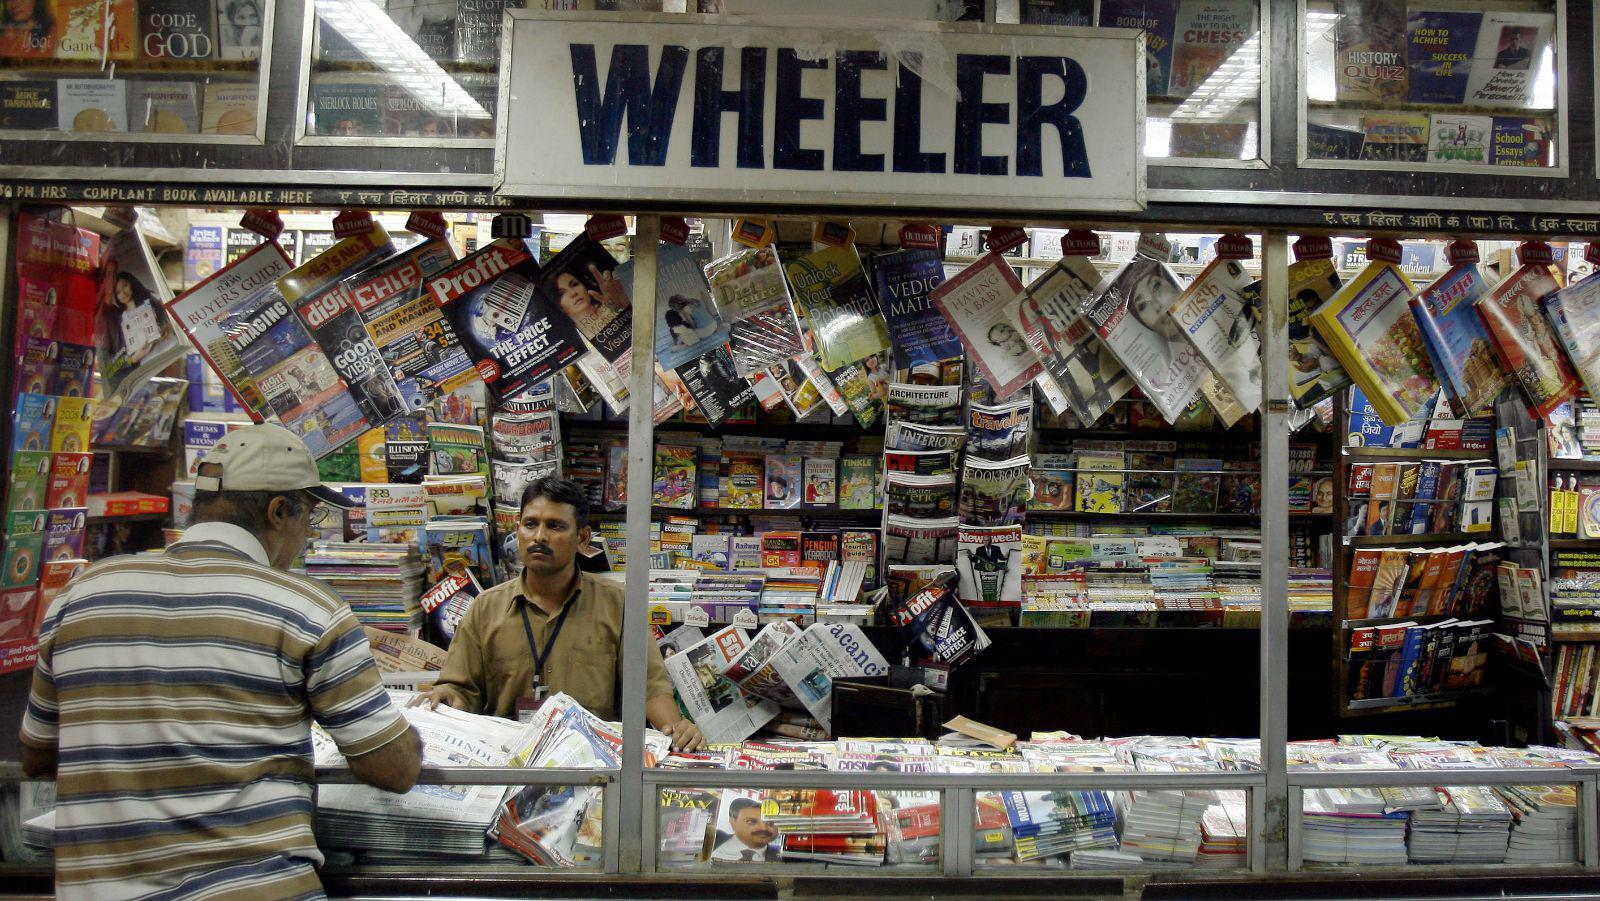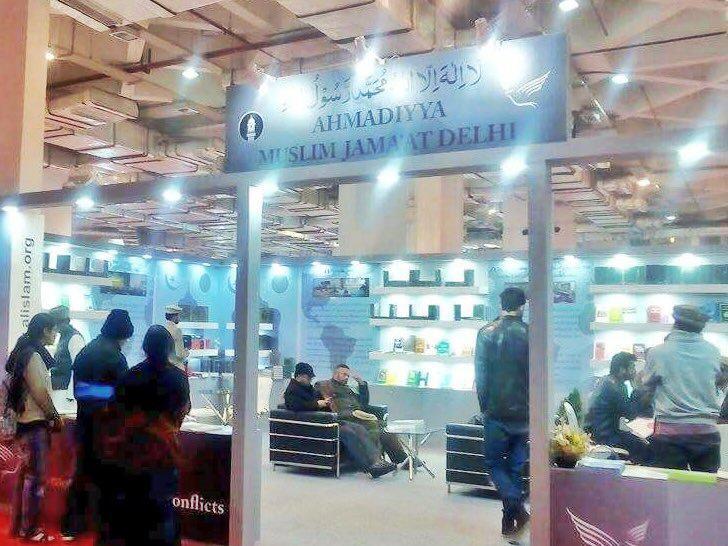The first image is the image on the left, the second image is the image on the right. For the images displayed, is the sentence "The sky is partially visible behind a book stall in the right image." factually correct? Answer yes or no. No. The first image is the image on the left, the second image is the image on the right. Considering the images on both sides, is "A vehicle is parked in the area near the sales in the image on the right." valid? Answer yes or no. No. 